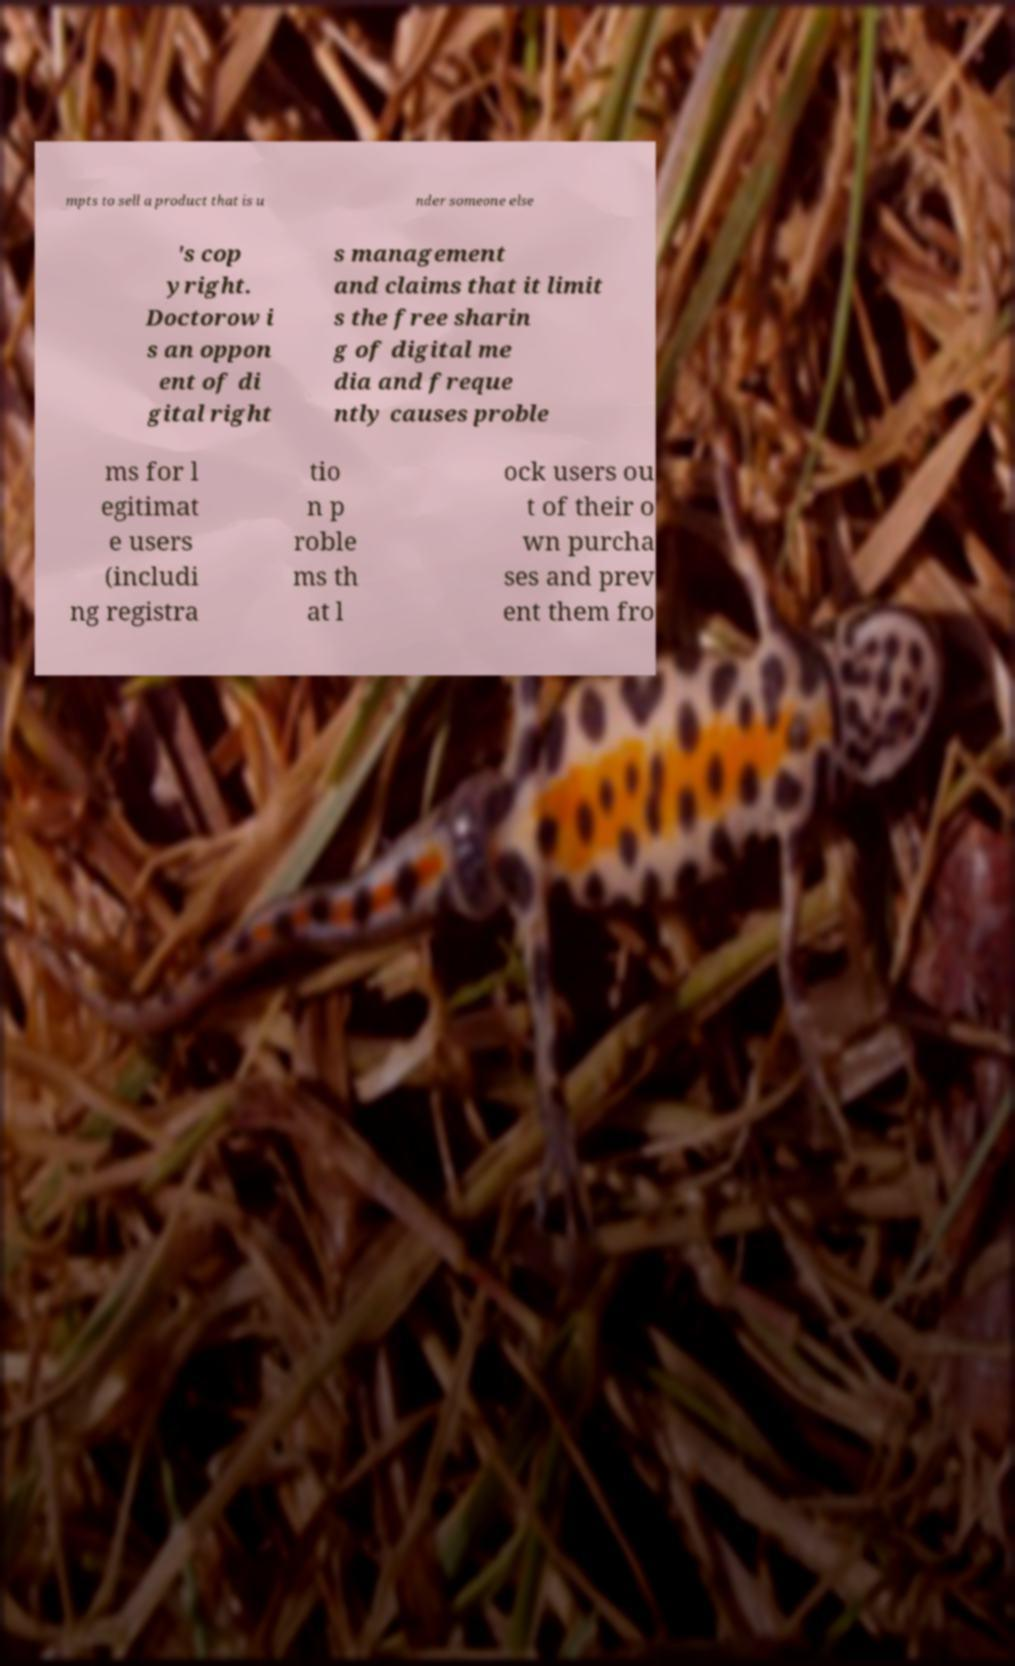Please identify and transcribe the text found in this image. mpts to sell a product that is u nder someone else 's cop yright. Doctorow i s an oppon ent of di gital right s management and claims that it limit s the free sharin g of digital me dia and freque ntly causes proble ms for l egitimat e users (includi ng registra tio n p roble ms th at l ock users ou t of their o wn purcha ses and prev ent them fro 